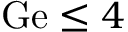<formula> <loc_0><loc_0><loc_500><loc_500>G e \leq 4</formula> 